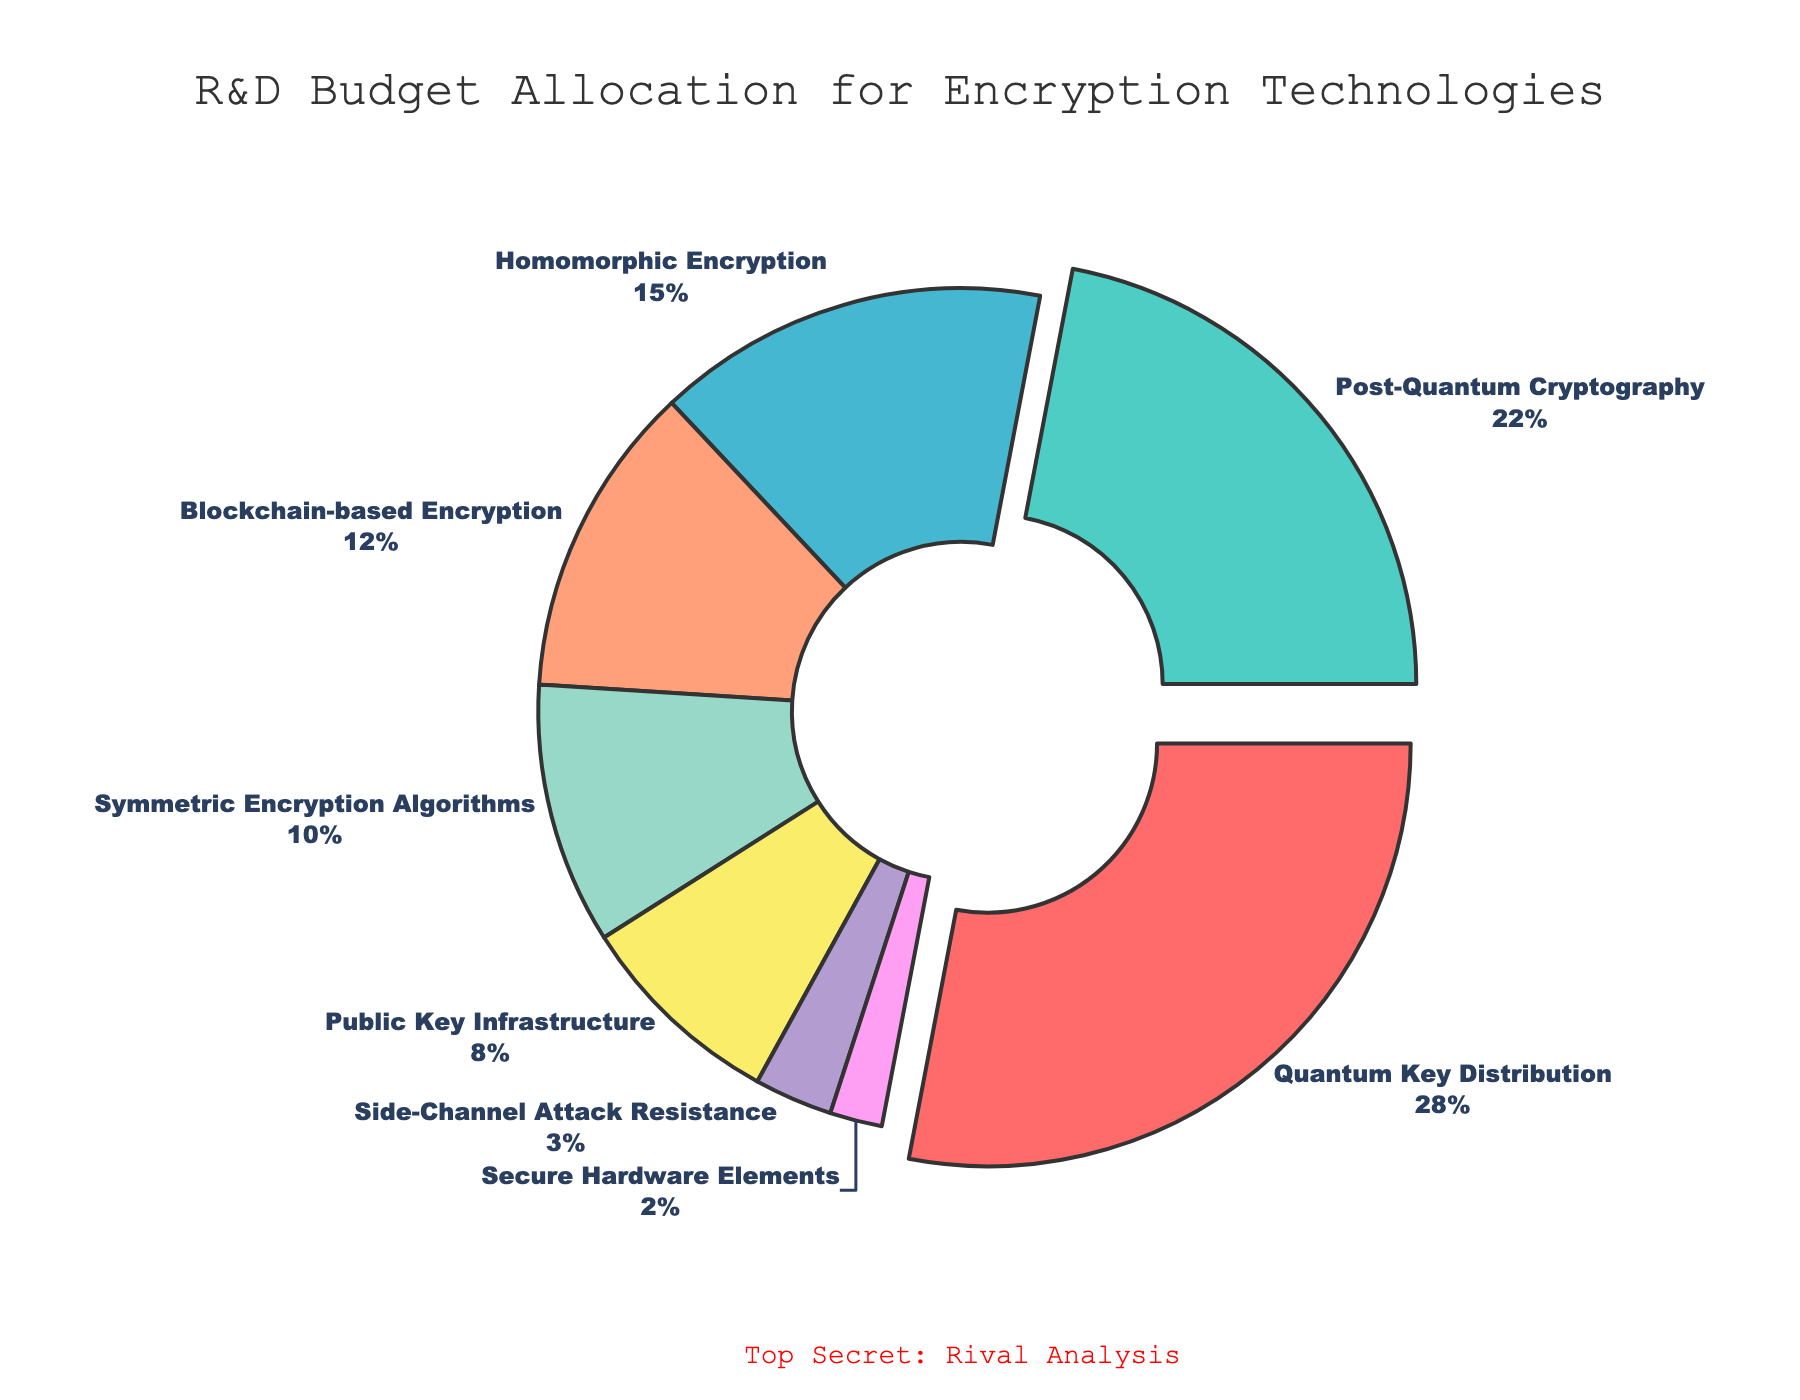What is the percentage allocation for Quantum Key Distribution? Quantum Key Distribution's percentage can be read directly from the pie chart at 28%.
Answer: 28% Which two technologies combined have the highest budget allocation? The technologies with the highest allocations are Quantum Key Distribution (28%) and Post-Quantum Cryptography (22%). Combined, they total 28% + 22% = 50%.
Answer: Quantum Key Distribution and Post-Quantum Cryptography What is the difference in budget allocation between Homomorphic Encryption and Blockchain-based Encryption? Homomorphic Encryption has a budget allocation of 15%, while Blockchain-based Encryption has 12%. The difference is 15% - 12% = 3%.
Answer: 3% How much more budget is allocated to Symmetric Encryption Algorithms compared to Secure Hardware Elements? Symmetric Encryption Algorithms have 10% of the budget, while Secure Hardware Elements have 2%. Therefore, the difference is 10% - 2% = 8%.
Answer: 8% Which technology receives the smallest budget allocation? The smallest budget allocation is for Secure Hardware Elements, which receive 2%.
Answer: Secure Hardware Elements If the total R&D budget is $10 million, what is the approximate budget allocated to Side-Channel Attack Resistance? Side-Channel Attack Resistance gets 3% of the total budget. 3% of $10 million is 0.03 * 10,000,000 = $300,000.
Answer: $300,000 What is the total percentage allocation for all the encryption technologies combined? Sum of all percentages: 28% (Quantum Key Distribution) + 22% (Post-Quantum Cryptography) + 15% (Homomorphic Encryption) + 12% (Blockchain-based Encryption) + 10% (Symmetric Encryption Algorithms) + 8% (Public Key Infrastructure) + 3% (Side-Channel Attack Resistance) + 2% (Secure Hardware Elements) = 100%.
Answer: 100% Which technology has the third-largest allocation and what is its percentage? The third largest allocation goes to Homomorphic Encryption at 15%.
Answer: Homomorphic Encryption, 15% Compare the budget allocation of Public Key Infrastructure to Side-Channel Attack Resistance. By what factor is Public Key Infrastructure's budget larger? Public Key Infrastructure has 8%, and Side-Channel Attack Resistance has 3%. 8% / 3% = 2.67. Public Key Infrastructure's budget is approximately 2.67 times larger.
Answer: 2.67 